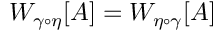<formula> <loc_0><loc_0><loc_500><loc_500>W _ { \gamma \circ \eta } [ A ] = W _ { \eta \circ \gamma } [ A ]</formula> 